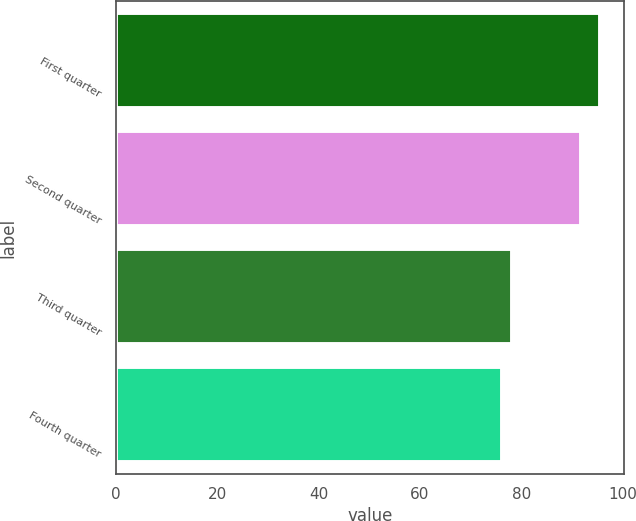Convert chart. <chart><loc_0><loc_0><loc_500><loc_500><bar_chart><fcel>First quarter<fcel>Second quarter<fcel>Third quarter<fcel>Fourth quarter<nl><fcel>95.5<fcel>91.85<fcel>78.13<fcel>76.2<nl></chart> 